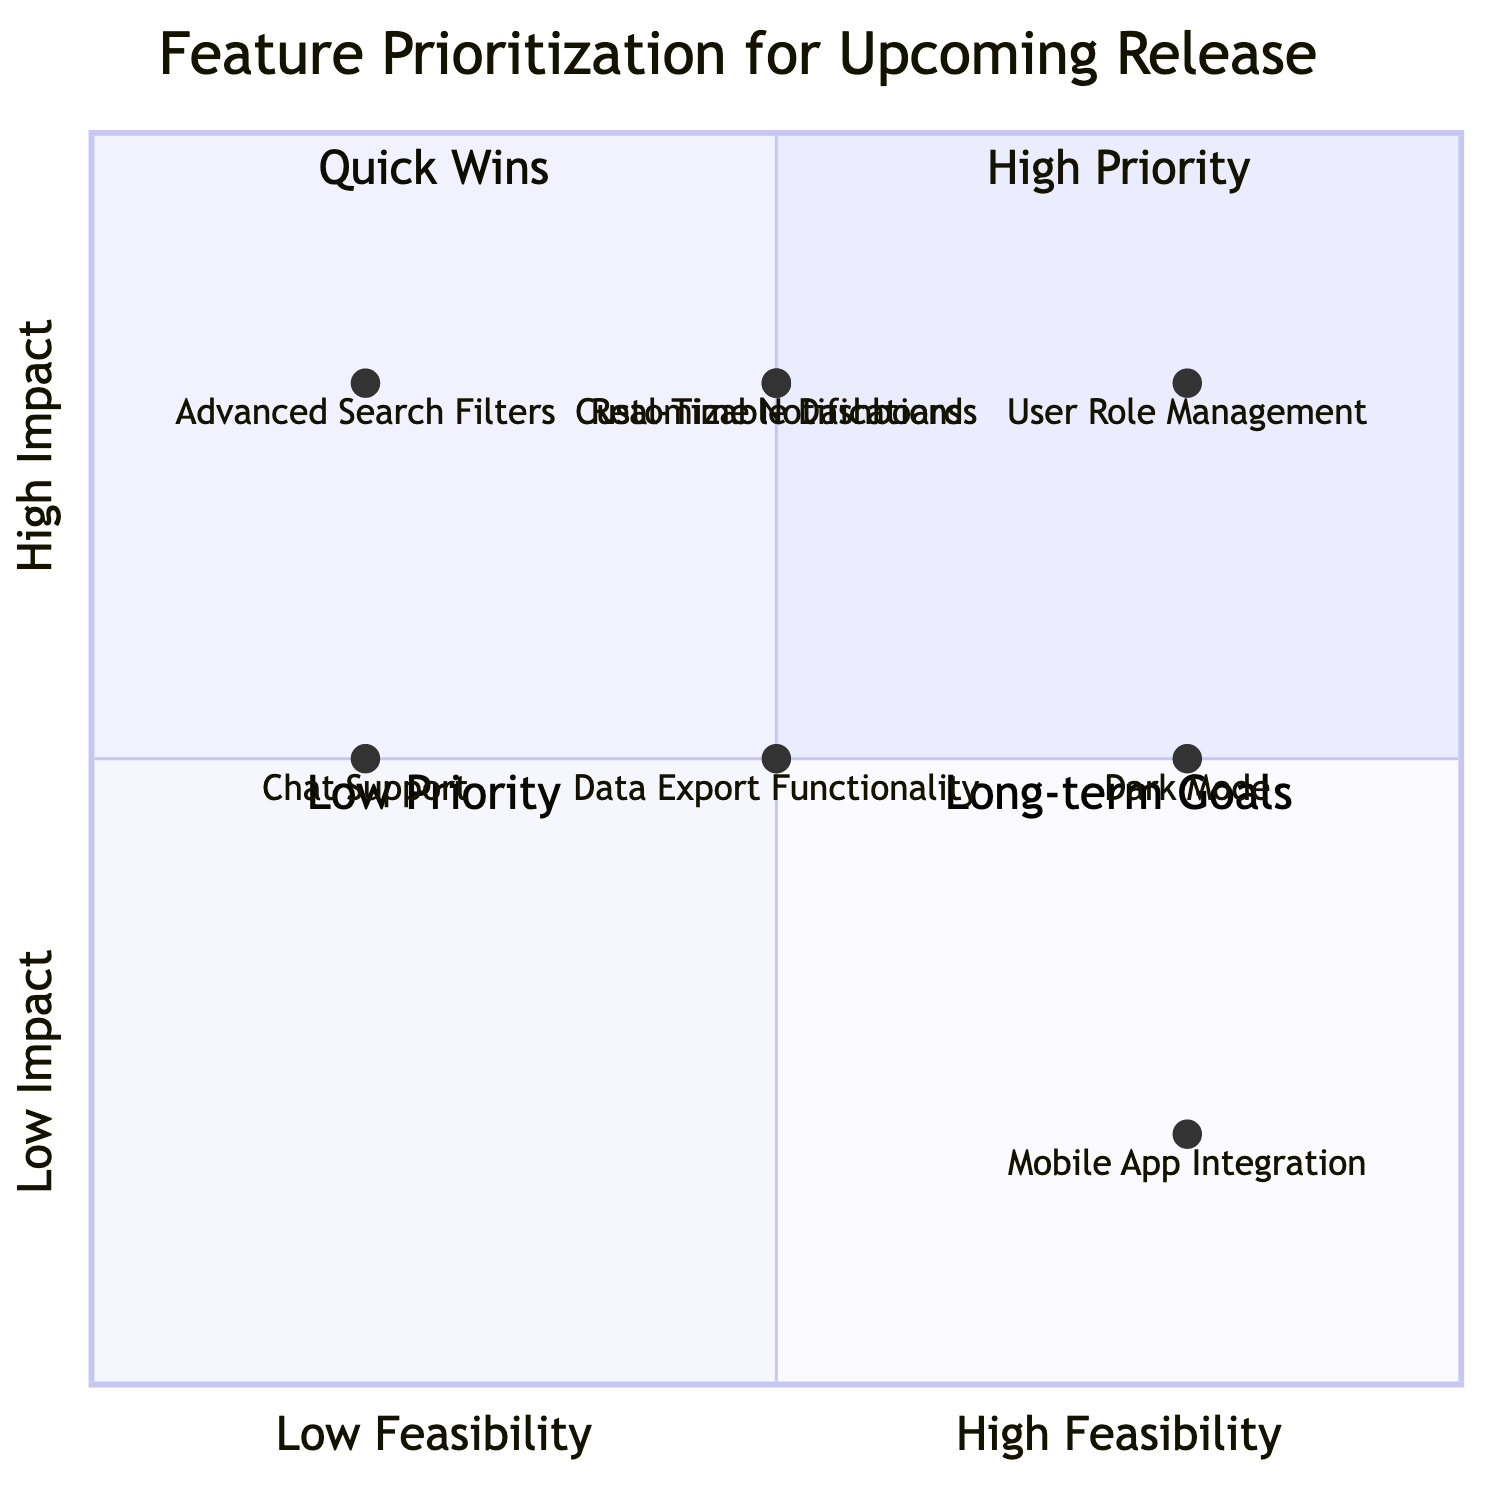What feature has the highest impact and feasibility? The feature "User Role Management" is located in the quadrant for high impact and high feasibility, indicating that it has both the highest level of impact and is highly feasible.
Answer: User Role Management How many features are categorized as high priority? The features "User Role Management," "Real-Time Notifications," "Customizable Dashboards," and "Advanced Search Filters" are plotted in the high priority quadrant, totaling four features.
Answer: Four Which feature is listed as a quick win? "Dark Mode" is plotted in the quadrant where feasibility is high and impact is medium, making it a quick win for implementation.
Answer: Dark Mode What is the feasibility level of "Advanced Search Filters"? "Advanced Search Filters" is plotted in the quadrant reflecting low feasibility, as indicated by its position on the x-axis towards low feasibility.
Answer: Low Which feature has medium impact and low feasibility? "Chat Support" is positioned in the quadrant that shows medium impact combined with low feasibility, making it the answer.
Answer: Chat Support Identify a feature with high impact but low feasibility. "Advanced Search Filters" is located in the high impact and low feasibility quadrant, representing a feature that is very impactful yet not easy to implement.
Answer: Advanced Search Filters How many features are categorized as long-term goals? Both "Chat Support" and "Advanced Search Filters" are located in the long-term goals quadrant, resulting in two features being categorized as such.
Answer: Two What is the impact level of the "Mobile App Integration" feature? The "Mobile App Integration" feature is plotted in the quadrant indicating low impact, as it is at the bottom left part of the chart, which corresponds to low impact.
Answer: Low Which feature has medium feasibility? "Real-Time Notifications," "Data Export Functionality," and "Customizable Dashboards" are all plotted in the medium feasibility position on the x-axis.
Answer: Real-Time Notifications, Data Export Functionality, Customizable Dashboards 